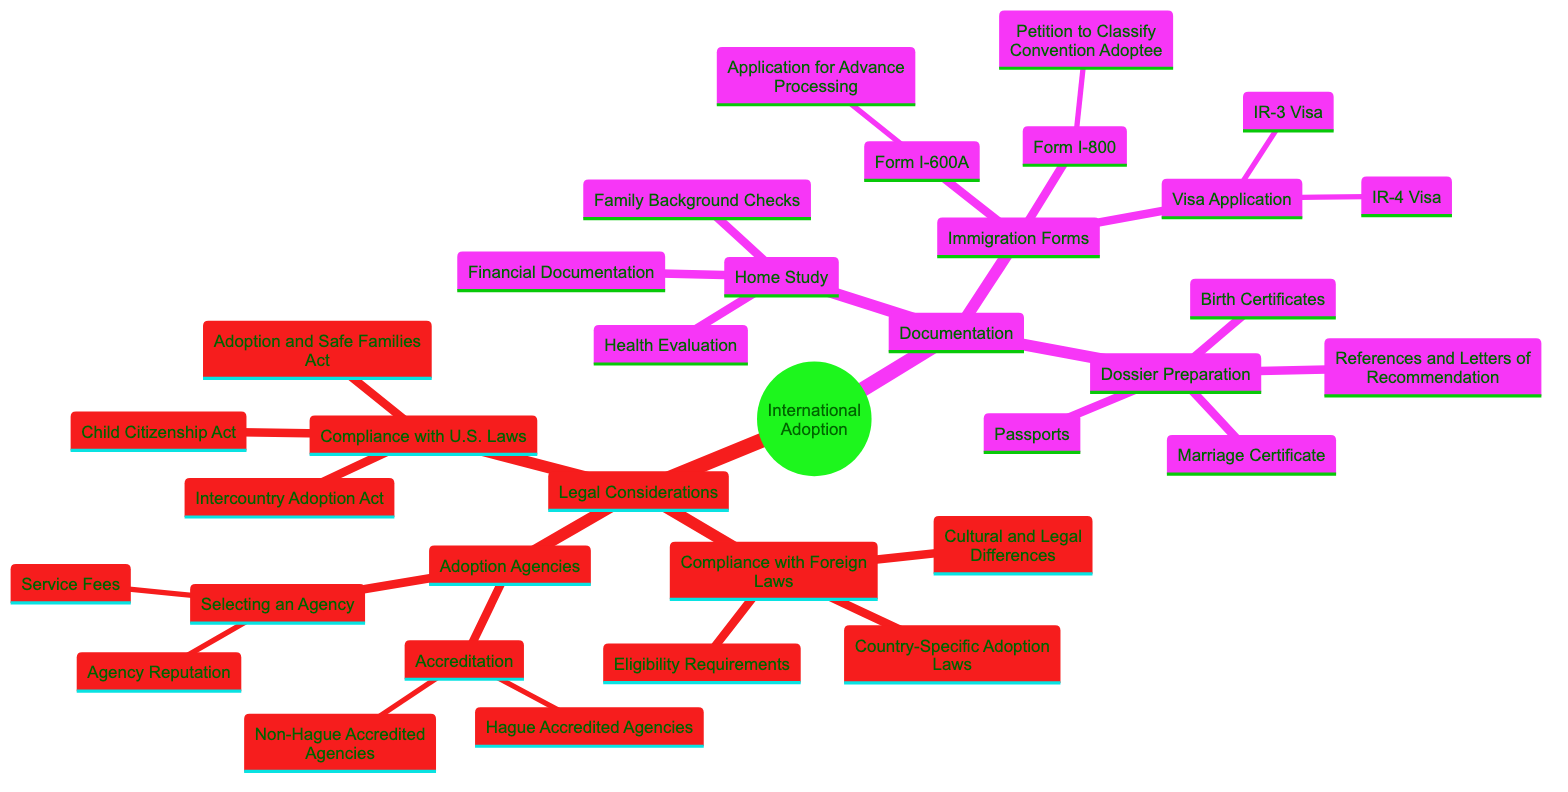What are the three compliance categories under U.S. Laws? The diagram lists three compliance categories namely: "Adoption and Safe Families Act", "Intercountry Adoption Act", and "Child Citizenship Act" under "Compliance with U.S. Laws".
Answer: Adoption and Safe Families Act, Intercountry Adoption Act, Child Citizenship Act How many types of adoption agencies are mentioned? The diagram identifies two main types of adoption agencies: "Hague Accredited Agencies" and "Non-Hague Accredited Agencies" under the "Accreditation" node.
Answer: 2 What type of visa application is mentioned in the diagram? The diagram includes two specific types of visa applications: "IR-3 Visa" and "IR-4 Visa" under the "Visa Application" node.
Answer: IR-3 Visa, IR-4 Visa What is required for the Dossier Preparation? The Dossier Preparation requires "Birth Certificates", "Marriage Certificate", "Passports", and "References and Letters of Recommendation" as indicated in the diagram.
Answer: Birth Certificates, Marriage Certificate, Passports, References and Letters of Recommendation How does compliance with foreign laws differ from compliance with U.S. laws? The diagram shows that "Compliance with Foreign Laws" includes "Country-Specific Adoption Laws", "Eligibility Requirements", and "Cultural and Legal Differences", while "Compliance with U.S. Laws" focuses on three specific U.S. laws indicating different scopes of compliance.
Answer: Different laws and requirements What is the purpose of Form I-600A? According to the diagram, Form I-600A is described as an "Application for Advance Processing", which is part of the immigration forms section related to international adoption.
Answer: Application for Advance Processing Which document is not part of the Home Study? The Home Study includes "Family Background Checks", "Financial Documentation", and "Health Evaluation", which indicates that "Dossier Preparation" is a different category, thus any elements from it do not belong to Home Study.
Answer: Dossier Preparation Which agency accreditation types are shown? The diagram presents two agency accreditation types under "Adoption Agencies": "Hague Accredited Agencies" and "Non-Hague Accredited Agencies".
Answer: Hague Accredited Agencies, Non-Hague Accredited Agencies How many components are in Dossier Preparation? The Dossier Preparation comprises four key components: "Birth Certificates", "Marriage Certificate", "Passports", and "References and Letters of Recommendation", as listed in the diagram.
Answer: 4 